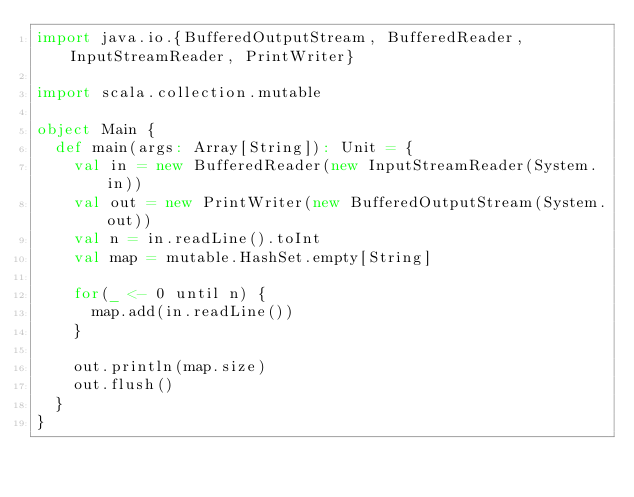Convert code to text. <code><loc_0><loc_0><loc_500><loc_500><_Scala_>import java.io.{BufferedOutputStream, BufferedReader, InputStreamReader, PrintWriter}

import scala.collection.mutable

object Main {
  def main(args: Array[String]): Unit = {
    val in = new BufferedReader(new InputStreamReader(System.in))
    val out = new PrintWriter(new BufferedOutputStream(System.out))
    val n = in.readLine().toInt
    val map = mutable.HashSet.empty[String]

    for(_ <- 0 until n) {
      map.add(in.readLine())
    }

    out.println(map.size)
    out.flush()
  }
}
</code> 